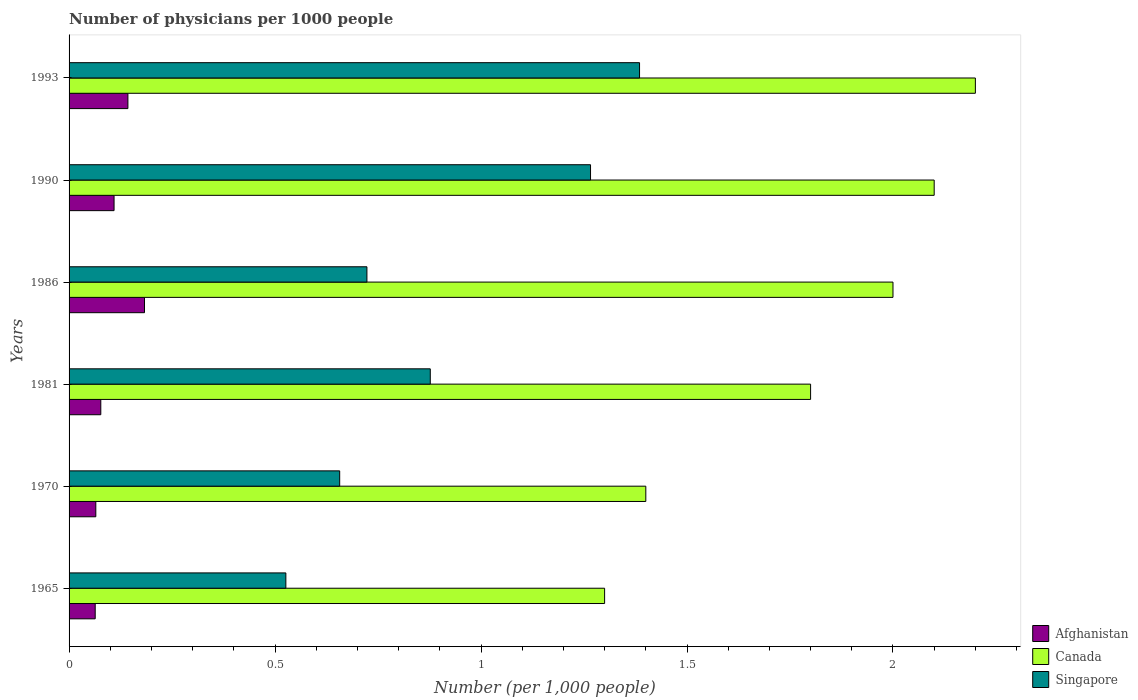How many different coloured bars are there?
Provide a short and direct response. 3. Are the number of bars on each tick of the Y-axis equal?
Keep it short and to the point. Yes. How many bars are there on the 4th tick from the bottom?
Make the answer very short. 3. What is the number of physicians in Afghanistan in 1990?
Provide a short and direct response. 0.11. Across all years, what is the maximum number of physicians in Singapore?
Offer a very short reply. 1.38. Across all years, what is the minimum number of physicians in Canada?
Offer a very short reply. 1.3. In which year was the number of physicians in Canada minimum?
Your answer should be very brief. 1965. What is the total number of physicians in Canada in the graph?
Ensure brevity in your answer.  10.8. What is the difference between the number of physicians in Canada in 1986 and that in 1993?
Give a very brief answer. -0.2. What is the difference between the number of physicians in Afghanistan in 1981 and the number of physicians in Canada in 1970?
Provide a succinct answer. -1.32. What is the average number of physicians in Canada per year?
Provide a succinct answer. 1.8. In the year 1990, what is the difference between the number of physicians in Canada and number of physicians in Afghanistan?
Keep it short and to the point. 1.99. In how many years, is the number of physicians in Canada greater than 2 ?
Your response must be concise. 2. What is the ratio of the number of physicians in Canada in 1986 to that in 1993?
Keep it short and to the point. 0.91. What is the difference between the highest and the second highest number of physicians in Afghanistan?
Offer a very short reply. 0.04. What is the difference between the highest and the lowest number of physicians in Singapore?
Offer a terse response. 0.86. Is the sum of the number of physicians in Singapore in 1965 and 1981 greater than the maximum number of physicians in Afghanistan across all years?
Keep it short and to the point. Yes. What does the 3rd bar from the bottom in 1986 represents?
Provide a short and direct response. Singapore. How many bars are there?
Your answer should be compact. 18. How many years are there in the graph?
Offer a very short reply. 6. Does the graph contain grids?
Ensure brevity in your answer.  No. How are the legend labels stacked?
Provide a succinct answer. Vertical. What is the title of the graph?
Ensure brevity in your answer.  Number of physicians per 1000 people. What is the label or title of the X-axis?
Give a very brief answer. Number (per 1,0 people). What is the Number (per 1,000 people) in Afghanistan in 1965?
Your response must be concise. 0.06. What is the Number (per 1,000 people) in Canada in 1965?
Offer a very short reply. 1.3. What is the Number (per 1,000 people) in Singapore in 1965?
Make the answer very short. 0.53. What is the Number (per 1,000 people) of Afghanistan in 1970?
Your answer should be very brief. 0.06. What is the Number (per 1,000 people) in Singapore in 1970?
Keep it short and to the point. 0.66. What is the Number (per 1,000 people) in Afghanistan in 1981?
Your response must be concise. 0.08. What is the Number (per 1,000 people) of Canada in 1981?
Make the answer very short. 1.8. What is the Number (per 1,000 people) in Singapore in 1981?
Your answer should be very brief. 0.88. What is the Number (per 1,000 people) of Afghanistan in 1986?
Offer a terse response. 0.18. What is the Number (per 1,000 people) in Canada in 1986?
Provide a succinct answer. 2. What is the Number (per 1,000 people) in Singapore in 1986?
Offer a very short reply. 0.72. What is the Number (per 1,000 people) of Afghanistan in 1990?
Your answer should be very brief. 0.11. What is the Number (per 1,000 people) in Singapore in 1990?
Offer a terse response. 1.27. What is the Number (per 1,000 people) in Afghanistan in 1993?
Your answer should be very brief. 0.14. What is the Number (per 1,000 people) in Singapore in 1993?
Provide a short and direct response. 1.38. Across all years, what is the maximum Number (per 1,000 people) in Afghanistan?
Your response must be concise. 0.18. Across all years, what is the maximum Number (per 1,000 people) in Canada?
Your answer should be very brief. 2.2. Across all years, what is the maximum Number (per 1,000 people) in Singapore?
Make the answer very short. 1.38. Across all years, what is the minimum Number (per 1,000 people) of Afghanistan?
Give a very brief answer. 0.06. Across all years, what is the minimum Number (per 1,000 people) in Canada?
Provide a succinct answer. 1.3. Across all years, what is the minimum Number (per 1,000 people) of Singapore?
Keep it short and to the point. 0.53. What is the total Number (per 1,000 people) in Afghanistan in the graph?
Ensure brevity in your answer.  0.64. What is the total Number (per 1,000 people) in Singapore in the graph?
Your answer should be very brief. 5.43. What is the difference between the Number (per 1,000 people) of Afghanistan in 1965 and that in 1970?
Provide a short and direct response. -0. What is the difference between the Number (per 1,000 people) in Singapore in 1965 and that in 1970?
Make the answer very short. -0.13. What is the difference between the Number (per 1,000 people) in Afghanistan in 1965 and that in 1981?
Offer a very short reply. -0.01. What is the difference between the Number (per 1,000 people) in Canada in 1965 and that in 1981?
Your answer should be very brief. -0.5. What is the difference between the Number (per 1,000 people) of Singapore in 1965 and that in 1981?
Offer a very short reply. -0.35. What is the difference between the Number (per 1,000 people) in Afghanistan in 1965 and that in 1986?
Give a very brief answer. -0.12. What is the difference between the Number (per 1,000 people) in Singapore in 1965 and that in 1986?
Keep it short and to the point. -0.2. What is the difference between the Number (per 1,000 people) of Afghanistan in 1965 and that in 1990?
Your answer should be compact. -0.05. What is the difference between the Number (per 1,000 people) of Canada in 1965 and that in 1990?
Ensure brevity in your answer.  -0.8. What is the difference between the Number (per 1,000 people) of Singapore in 1965 and that in 1990?
Your response must be concise. -0.74. What is the difference between the Number (per 1,000 people) of Afghanistan in 1965 and that in 1993?
Ensure brevity in your answer.  -0.08. What is the difference between the Number (per 1,000 people) in Singapore in 1965 and that in 1993?
Make the answer very short. -0.86. What is the difference between the Number (per 1,000 people) in Afghanistan in 1970 and that in 1981?
Give a very brief answer. -0.01. What is the difference between the Number (per 1,000 people) in Canada in 1970 and that in 1981?
Give a very brief answer. -0.4. What is the difference between the Number (per 1,000 people) of Singapore in 1970 and that in 1981?
Make the answer very short. -0.22. What is the difference between the Number (per 1,000 people) in Afghanistan in 1970 and that in 1986?
Offer a very short reply. -0.12. What is the difference between the Number (per 1,000 people) in Canada in 1970 and that in 1986?
Provide a succinct answer. -0.6. What is the difference between the Number (per 1,000 people) in Singapore in 1970 and that in 1986?
Provide a short and direct response. -0.07. What is the difference between the Number (per 1,000 people) in Afghanistan in 1970 and that in 1990?
Your answer should be compact. -0.04. What is the difference between the Number (per 1,000 people) of Singapore in 1970 and that in 1990?
Offer a terse response. -0.61. What is the difference between the Number (per 1,000 people) in Afghanistan in 1970 and that in 1993?
Offer a very short reply. -0.08. What is the difference between the Number (per 1,000 people) in Singapore in 1970 and that in 1993?
Make the answer very short. -0.73. What is the difference between the Number (per 1,000 people) in Afghanistan in 1981 and that in 1986?
Offer a terse response. -0.11. What is the difference between the Number (per 1,000 people) in Singapore in 1981 and that in 1986?
Give a very brief answer. 0.15. What is the difference between the Number (per 1,000 people) in Afghanistan in 1981 and that in 1990?
Offer a terse response. -0.03. What is the difference between the Number (per 1,000 people) in Canada in 1981 and that in 1990?
Offer a very short reply. -0.3. What is the difference between the Number (per 1,000 people) in Singapore in 1981 and that in 1990?
Your answer should be compact. -0.39. What is the difference between the Number (per 1,000 people) in Afghanistan in 1981 and that in 1993?
Make the answer very short. -0.07. What is the difference between the Number (per 1,000 people) in Singapore in 1981 and that in 1993?
Provide a short and direct response. -0.51. What is the difference between the Number (per 1,000 people) in Afghanistan in 1986 and that in 1990?
Provide a short and direct response. 0.07. What is the difference between the Number (per 1,000 people) in Singapore in 1986 and that in 1990?
Keep it short and to the point. -0.54. What is the difference between the Number (per 1,000 people) in Afghanistan in 1986 and that in 1993?
Make the answer very short. 0.04. What is the difference between the Number (per 1,000 people) of Canada in 1986 and that in 1993?
Offer a very short reply. -0.2. What is the difference between the Number (per 1,000 people) in Singapore in 1986 and that in 1993?
Your answer should be very brief. -0.66. What is the difference between the Number (per 1,000 people) in Afghanistan in 1990 and that in 1993?
Your response must be concise. -0.03. What is the difference between the Number (per 1,000 people) in Singapore in 1990 and that in 1993?
Ensure brevity in your answer.  -0.12. What is the difference between the Number (per 1,000 people) of Afghanistan in 1965 and the Number (per 1,000 people) of Canada in 1970?
Offer a very short reply. -1.34. What is the difference between the Number (per 1,000 people) of Afghanistan in 1965 and the Number (per 1,000 people) of Singapore in 1970?
Ensure brevity in your answer.  -0.59. What is the difference between the Number (per 1,000 people) in Canada in 1965 and the Number (per 1,000 people) in Singapore in 1970?
Give a very brief answer. 0.64. What is the difference between the Number (per 1,000 people) of Afghanistan in 1965 and the Number (per 1,000 people) of Canada in 1981?
Make the answer very short. -1.74. What is the difference between the Number (per 1,000 people) of Afghanistan in 1965 and the Number (per 1,000 people) of Singapore in 1981?
Your answer should be compact. -0.81. What is the difference between the Number (per 1,000 people) in Canada in 1965 and the Number (per 1,000 people) in Singapore in 1981?
Your answer should be very brief. 0.42. What is the difference between the Number (per 1,000 people) of Afghanistan in 1965 and the Number (per 1,000 people) of Canada in 1986?
Your answer should be compact. -1.94. What is the difference between the Number (per 1,000 people) in Afghanistan in 1965 and the Number (per 1,000 people) in Singapore in 1986?
Your answer should be compact. -0.66. What is the difference between the Number (per 1,000 people) of Canada in 1965 and the Number (per 1,000 people) of Singapore in 1986?
Give a very brief answer. 0.58. What is the difference between the Number (per 1,000 people) of Afghanistan in 1965 and the Number (per 1,000 people) of Canada in 1990?
Offer a very short reply. -2.04. What is the difference between the Number (per 1,000 people) of Afghanistan in 1965 and the Number (per 1,000 people) of Singapore in 1990?
Make the answer very short. -1.2. What is the difference between the Number (per 1,000 people) in Canada in 1965 and the Number (per 1,000 people) in Singapore in 1990?
Ensure brevity in your answer.  0.03. What is the difference between the Number (per 1,000 people) in Afghanistan in 1965 and the Number (per 1,000 people) in Canada in 1993?
Your answer should be very brief. -2.14. What is the difference between the Number (per 1,000 people) in Afghanistan in 1965 and the Number (per 1,000 people) in Singapore in 1993?
Keep it short and to the point. -1.32. What is the difference between the Number (per 1,000 people) of Canada in 1965 and the Number (per 1,000 people) of Singapore in 1993?
Give a very brief answer. -0.08. What is the difference between the Number (per 1,000 people) in Afghanistan in 1970 and the Number (per 1,000 people) in Canada in 1981?
Your answer should be compact. -1.74. What is the difference between the Number (per 1,000 people) in Afghanistan in 1970 and the Number (per 1,000 people) in Singapore in 1981?
Keep it short and to the point. -0.81. What is the difference between the Number (per 1,000 people) in Canada in 1970 and the Number (per 1,000 people) in Singapore in 1981?
Make the answer very short. 0.52. What is the difference between the Number (per 1,000 people) in Afghanistan in 1970 and the Number (per 1,000 people) in Canada in 1986?
Your answer should be compact. -1.94. What is the difference between the Number (per 1,000 people) in Afghanistan in 1970 and the Number (per 1,000 people) in Singapore in 1986?
Give a very brief answer. -0.66. What is the difference between the Number (per 1,000 people) in Canada in 1970 and the Number (per 1,000 people) in Singapore in 1986?
Ensure brevity in your answer.  0.68. What is the difference between the Number (per 1,000 people) in Afghanistan in 1970 and the Number (per 1,000 people) in Canada in 1990?
Keep it short and to the point. -2.04. What is the difference between the Number (per 1,000 people) of Afghanistan in 1970 and the Number (per 1,000 people) of Singapore in 1990?
Your answer should be compact. -1.2. What is the difference between the Number (per 1,000 people) of Canada in 1970 and the Number (per 1,000 people) of Singapore in 1990?
Offer a terse response. 0.13. What is the difference between the Number (per 1,000 people) in Afghanistan in 1970 and the Number (per 1,000 people) in Canada in 1993?
Your response must be concise. -2.14. What is the difference between the Number (per 1,000 people) in Afghanistan in 1970 and the Number (per 1,000 people) in Singapore in 1993?
Provide a succinct answer. -1.32. What is the difference between the Number (per 1,000 people) of Canada in 1970 and the Number (per 1,000 people) of Singapore in 1993?
Ensure brevity in your answer.  0.02. What is the difference between the Number (per 1,000 people) in Afghanistan in 1981 and the Number (per 1,000 people) in Canada in 1986?
Your answer should be very brief. -1.92. What is the difference between the Number (per 1,000 people) of Afghanistan in 1981 and the Number (per 1,000 people) of Singapore in 1986?
Your answer should be compact. -0.65. What is the difference between the Number (per 1,000 people) of Canada in 1981 and the Number (per 1,000 people) of Singapore in 1986?
Offer a terse response. 1.08. What is the difference between the Number (per 1,000 people) of Afghanistan in 1981 and the Number (per 1,000 people) of Canada in 1990?
Your answer should be compact. -2.02. What is the difference between the Number (per 1,000 people) in Afghanistan in 1981 and the Number (per 1,000 people) in Singapore in 1990?
Your response must be concise. -1.19. What is the difference between the Number (per 1,000 people) of Canada in 1981 and the Number (per 1,000 people) of Singapore in 1990?
Provide a succinct answer. 0.53. What is the difference between the Number (per 1,000 people) of Afghanistan in 1981 and the Number (per 1,000 people) of Canada in 1993?
Provide a short and direct response. -2.12. What is the difference between the Number (per 1,000 people) in Afghanistan in 1981 and the Number (per 1,000 people) in Singapore in 1993?
Ensure brevity in your answer.  -1.31. What is the difference between the Number (per 1,000 people) in Canada in 1981 and the Number (per 1,000 people) in Singapore in 1993?
Your response must be concise. 0.42. What is the difference between the Number (per 1,000 people) in Afghanistan in 1986 and the Number (per 1,000 people) in Canada in 1990?
Give a very brief answer. -1.92. What is the difference between the Number (per 1,000 people) in Afghanistan in 1986 and the Number (per 1,000 people) in Singapore in 1990?
Your answer should be compact. -1.08. What is the difference between the Number (per 1,000 people) of Canada in 1986 and the Number (per 1,000 people) of Singapore in 1990?
Your answer should be very brief. 0.73. What is the difference between the Number (per 1,000 people) of Afghanistan in 1986 and the Number (per 1,000 people) of Canada in 1993?
Make the answer very short. -2.02. What is the difference between the Number (per 1,000 people) of Afghanistan in 1986 and the Number (per 1,000 people) of Singapore in 1993?
Provide a succinct answer. -1.2. What is the difference between the Number (per 1,000 people) of Canada in 1986 and the Number (per 1,000 people) of Singapore in 1993?
Provide a succinct answer. 0.62. What is the difference between the Number (per 1,000 people) in Afghanistan in 1990 and the Number (per 1,000 people) in Canada in 1993?
Offer a terse response. -2.09. What is the difference between the Number (per 1,000 people) of Afghanistan in 1990 and the Number (per 1,000 people) of Singapore in 1993?
Make the answer very short. -1.28. What is the difference between the Number (per 1,000 people) in Canada in 1990 and the Number (per 1,000 people) in Singapore in 1993?
Provide a succinct answer. 0.72. What is the average Number (per 1,000 people) in Afghanistan per year?
Offer a terse response. 0.11. What is the average Number (per 1,000 people) in Canada per year?
Provide a succinct answer. 1.8. What is the average Number (per 1,000 people) in Singapore per year?
Ensure brevity in your answer.  0.91. In the year 1965, what is the difference between the Number (per 1,000 people) in Afghanistan and Number (per 1,000 people) in Canada?
Offer a terse response. -1.24. In the year 1965, what is the difference between the Number (per 1,000 people) in Afghanistan and Number (per 1,000 people) in Singapore?
Offer a very short reply. -0.46. In the year 1965, what is the difference between the Number (per 1,000 people) of Canada and Number (per 1,000 people) of Singapore?
Keep it short and to the point. 0.77. In the year 1970, what is the difference between the Number (per 1,000 people) of Afghanistan and Number (per 1,000 people) of Canada?
Provide a succinct answer. -1.34. In the year 1970, what is the difference between the Number (per 1,000 people) of Afghanistan and Number (per 1,000 people) of Singapore?
Provide a short and direct response. -0.59. In the year 1970, what is the difference between the Number (per 1,000 people) of Canada and Number (per 1,000 people) of Singapore?
Your answer should be very brief. 0.74. In the year 1981, what is the difference between the Number (per 1,000 people) of Afghanistan and Number (per 1,000 people) of Canada?
Keep it short and to the point. -1.72. In the year 1981, what is the difference between the Number (per 1,000 people) in Afghanistan and Number (per 1,000 people) in Singapore?
Provide a succinct answer. -0.8. In the year 1981, what is the difference between the Number (per 1,000 people) in Canada and Number (per 1,000 people) in Singapore?
Your response must be concise. 0.92. In the year 1986, what is the difference between the Number (per 1,000 people) in Afghanistan and Number (per 1,000 people) in Canada?
Provide a succinct answer. -1.82. In the year 1986, what is the difference between the Number (per 1,000 people) of Afghanistan and Number (per 1,000 people) of Singapore?
Your answer should be very brief. -0.54. In the year 1986, what is the difference between the Number (per 1,000 people) of Canada and Number (per 1,000 people) of Singapore?
Keep it short and to the point. 1.28. In the year 1990, what is the difference between the Number (per 1,000 people) in Afghanistan and Number (per 1,000 people) in Canada?
Your response must be concise. -1.99. In the year 1990, what is the difference between the Number (per 1,000 people) in Afghanistan and Number (per 1,000 people) in Singapore?
Keep it short and to the point. -1.16. In the year 1990, what is the difference between the Number (per 1,000 people) in Canada and Number (per 1,000 people) in Singapore?
Make the answer very short. 0.83. In the year 1993, what is the difference between the Number (per 1,000 people) in Afghanistan and Number (per 1,000 people) in Canada?
Offer a terse response. -2.06. In the year 1993, what is the difference between the Number (per 1,000 people) in Afghanistan and Number (per 1,000 people) in Singapore?
Offer a terse response. -1.24. In the year 1993, what is the difference between the Number (per 1,000 people) of Canada and Number (per 1,000 people) of Singapore?
Give a very brief answer. 0.82. What is the ratio of the Number (per 1,000 people) in Afghanistan in 1965 to that in 1970?
Ensure brevity in your answer.  0.98. What is the ratio of the Number (per 1,000 people) of Canada in 1965 to that in 1970?
Offer a terse response. 0.93. What is the ratio of the Number (per 1,000 people) of Singapore in 1965 to that in 1970?
Give a very brief answer. 0.8. What is the ratio of the Number (per 1,000 people) in Afghanistan in 1965 to that in 1981?
Give a very brief answer. 0.82. What is the ratio of the Number (per 1,000 people) of Canada in 1965 to that in 1981?
Ensure brevity in your answer.  0.72. What is the ratio of the Number (per 1,000 people) in Singapore in 1965 to that in 1981?
Offer a very short reply. 0.6. What is the ratio of the Number (per 1,000 people) of Afghanistan in 1965 to that in 1986?
Make the answer very short. 0.35. What is the ratio of the Number (per 1,000 people) in Canada in 1965 to that in 1986?
Make the answer very short. 0.65. What is the ratio of the Number (per 1,000 people) of Singapore in 1965 to that in 1986?
Give a very brief answer. 0.73. What is the ratio of the Number (per 1,000 people) in Afghanistan in 1965 to that in 1990?
Ensure brevity in your answer.  0.58. What is the ratio of the Number (per 1,000 people) in Canada in 1965 to that in 1990?
Give a very brief answer. 0.62. What is the ratio of the Number (per 1,000 people) of Singapore in 1965 to that in 1990?
Offer a very short reply. 0.42. What is the ratio of the Number (per 1,000 people) of Afghanistan in 1965 to that in 1993?
Make the answer very short. 0.44. What is the ratio of the Number (per 1,000 people) in Canada in 1965 to that in 1993?
Provide a succinct answer. 0.59. What is the ratio of the Number (per 1,000 people) in Singapore in 1965 to that in 1993?
Offer a terse response. 0.38. What is the ratio of the Number (per 1,000 people) of Afghanistan in 1970 to that in 1981?
Offer a terse response. 0.84. What is the ratio of the Number (per 1,000 people) in Canada in 1970 to that in 1981?
Offer a very short reply. 0.78. What is the ratio of the Number (per 1,000 people) of Singapore in 1970 to that in 1981?
Offer a very short reply. 0.75. What is the ratio of the Number (per 1,000 people) of Afghanistan in 1970 to that in 1986?
Ensure brevity in your answer.  0.35. What is the ratio of the Number (per 1,000 people) of Canada in 1970 to that in 1986?
Your response must be concise. 0.7. What is the ratio of the Number (per 1,000 people) of Singapore in 1970 to that in 1986?
Your answer should be very brief. 0.91. What is the ratio of the Number (per 1,000 people) of Afghanistan in 1970 to that in 1990?
Give a very brief answer. 0.59. What is the ratio of the Number (per 1,000 people) of Canada in 1970 to that in 1990?
Offer a terse response. 0.67. What is the ratio of the Number (per 1,000 people) of Singapore in 1970 to that in 1990?
Your answer should be very brief. 0.52. What is the ratio of the Number (per 1,000 people) of Afghanistan in 1970 to that in 1993?
Keep it short and to the point. 0.45. What is the ratio of the Number (per 1,000 people) in Canada in 1970 to that in 1993?
Provide a succinct answer. 0.64. What is the ratio of the Number (per 1,000 people) of Singapore in 1970 to that in 1993?
Offer a very short reply. 0.47. What is the ratio of the Number (per 1,000 people) in Afghanistan in 1981 to that in 1986?
Give a very brief answer. 0.42. What is the ratio of the Number (per 1,000 people) of Singapore in 1981 to that in 1986?
Make the answer very short. 1.21. What is the ratio of the Number (per 1,000 people) in Afghanistan in 1981 to that in 1990?
Make the answer very short. 0.71. What is the ratio of the Number (per 1,000 people) of Singapore in 1981 to that in 1990?
Provide a short and direct response. 0.69. What is the ratio of the Number (per 1,000 people) of Afghanistan in 1981 to that in 1993?
Make the answer very short. 0.54. What is the ratio of the Number (per 1,000 people) in Canada in 1981 to that in 1993?
Your answer should be compact. 0.82. What is the ratio of the Number (per 1,000 people) of Singapore in 1981 to that in 1993?
Your response must be concise. 0.63. What is the ratio of the Number (per 1,000 people) of Afghanistan in 1986 to that in 1990?
Your response must be concise. 1.68. What is the ratio of the Number (per 1,000 people) in Canada in 1986 to that in 1990?
Offer a very short reply. 0.95. What is the ratio of the Number (per 1,000 people) in Singapore in 1986 to that in 1990?
Make the answer very short. 0.57. What is the ratio of the Number (per 1,000 people) of Afghanistan in 1986 to that in 1993?
Your answer should be very brief. 1.28. What is the ratio of the Number (per 1,000 people) of Canada in 1986 to that in 1993?
Keep it short and to the point. 0.91. What is the ratio of the Number (per 1,000 people) of Singapore in 1986 to that in 1993?
Your answer should be very brief. 0.52. What is the ratio of the Number (per 1,000 people) in Afghanistan in 1990 to that in 1993?
Offer a terse response. 0.76. What is the ratio of the Number (per 1,000 people) in Canada in 1990 to that in 1993?
Your response must be concise. 0.95. What is the ratio of the Number (per 1,000 people) of Singapore in 1990 to that in 1993?
Ensure brevity in your answer.  0.91. What is the difference between the highest and the second highest Number (per 1,000 people) of Afghanistan?
Make the answer very short. 0.04. What is the difference between the highest and the second highest Number (per 1,000 people) in Canada?
Keep it short and to the point. 0.1. What is the difference between the highest and the second highest Number (per 1,000 people) of Singapore?
Offer a terse response. 0.12. What is the difference between the highest and the lowest Number (per 1,000 people) of Afghanistan?
Offer a very short reply. 0.12. What is the difference between the highest and the lowest Number (per 1,000 people) of Singapore?
Offer a very short reply. 0.86. 